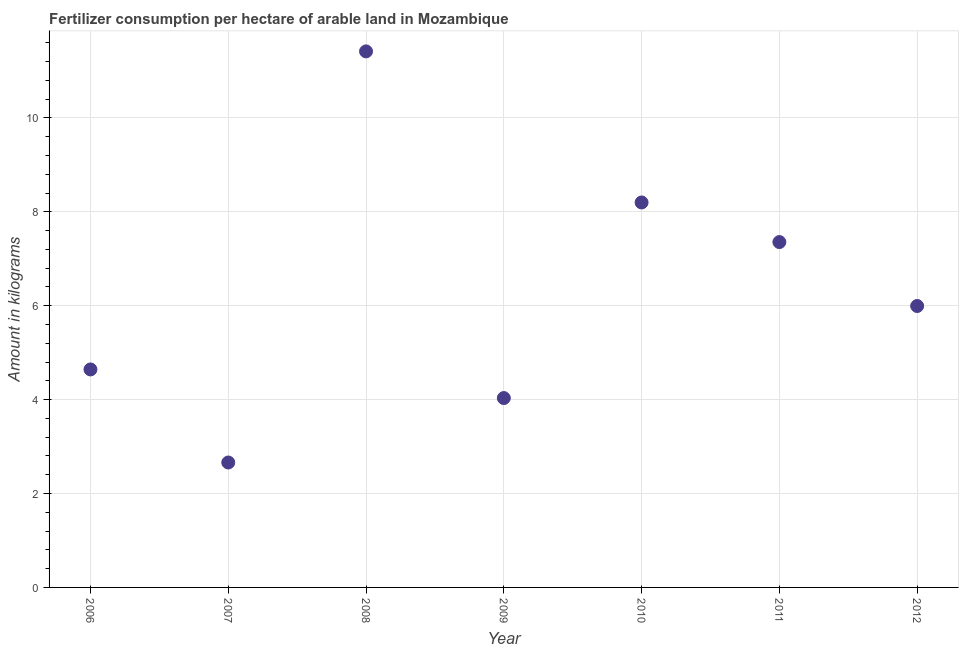What is the amount of fertilizer consumption in 2007?
Provide a short and direct response. 2.66. Across all years, what is the maximum amount of fertilizer consumption?
Your answer should be very brief. 11.42. Across all years, what is the minimum amount of fertilizer consumption?
Provide a short and direct response. 2.66. In which year was the amount of fertilizer consumption maximum?
Make the answer very short. 2008. In which year was the amount of fertilizer consumption minimum?
Your answer should be compact. 2007. What is the sum of the amount of fertilizer consumption?
Offer a terse response. 44.3. What is the difference between the amount of fertilizer consumption in 2009 and 2011?
Make the answer very short. -3.32. What is the average amount of fertilizer consumption per year?
Your answer should be very brief. 6.33. What is the median amount of fertilizer consumption?
Provide a short and direct response. 5.99. Do a majority of the years between 2012 and 2010 (inclusive) have amount of fertilizer consumption greater than 5.6 kg?
Keep it short and to the point. No. What is the ratio of the amount of fertilizer consumption in 2006 to that in 2011?
Provide a short and direct response. 0.63. Is the amount of fertilizer consumption in 2007 less than that in 2011?
Offer a very short reply. Yes. What is the difference between the highest and the second highest amount of fertilizer consumption?
Provide a succinct answer. 3.22. What is the difference between the highest and the lowest amount of fertilizer consumption?
Make the answer very short. 8.76. In how many years, is the amount of fertilizer consumption greater than the average amount of fertilizer consumption taken over all years?
Make the answer very short. 3. How many years are there in the graph?
Provide a short and direct response. 7. What is the difference between two consecutive major ticks on the Y-axis?
Your answer should be very brief. 2. Does the graph contain grids?
Your response must be concise. Yes. What is the title of the graph?
Offer a very short reply. Fertilizer consumption per hectare of arable land in Mozambique . What is the label or title of the Y-axis?
Provide a succinct answer. Amount in kilograms. What is the Amount in kilograms in 2006?
Provide a short and direct response. 4.64. What is the Amount in kilograms in 2007?
Give a very brief answer. 2.66. What is the Amount in kilograms in 2008?
Your response must be concise. 11.42. What is the Amount in kilograms in 2009?
Offer a very short reply. 4.03. What is the Amount in kilograms in 2010?
Give a very brief answer. 8.2. What is the Amount in kilograms in 2011?
Your answer should be compact. 7.36. What is the Amount in kilograms in 2012?
Your answer should be compact. 5.99. What is the difference between the Amount in kilograms in 2006 and 2007?
Offer a terse response. 1.98. What is the difference between the Amount in kilograms in 2006 and 2008?
Your answer should be very brief. -6.77. What is the difference between the Amount in kilograms in 2006 and 2009?
Ensure brevity in your answer.  0.61. What is the difference between the Amount in kilograms in 2006 and 2010?
Offer a very short reply. -3.56. What is the difference between the Amount in kilograms in 2006 and 2011?
Provide a succinct answer. -2.71. What is the difference between the Amount in kilograms in 2006 and 2012?
Your answer should be very brief. -1.35. What is the difference between the Amount in kilograms in 2007 and 2008?
Give a very brief answer. -8.76. What is the difference between the Amount in kilograms in 2007 and 2009?
Offer a terse response. -1.37. What is the difference between the Amount in kilograms in 2007 and 2010?
Ensure brevity in your answer.  -5.54. What is the difference between the Amount in kilograms in 2007 and 2011?
Provide a short and direct response. -4.7. What is the difference between the Amount in kilograms in 2007 and 2012?
Your answer should be very brief. -3.33. What is the difference between the Amount in kilograms in 2008 and 2009?
Provide a short and direct response. 7.38. What is the difference between the Amount in kilograms in 2008 and 2010?
Ensure brevity in your answer.  3.22. What is the difference between the Amount in kilograms in 2008 and 2011?
Your answer should be compact. 4.06. What is the difference between the Amount in kilograms in 2008 and 2012?
Keep it short and to the point. 5.42. What is the difference between the Amount in kilograms in 2009 and 2010?
Ensure brevity in your answer.  -4.17. What is the difference between the Amount in kilograms in 2009 and 2011?
Provide a succinct answer. -3.32. What is the difference between the Amount in kilograms in 2009 and 2012?
Your answer should be compact. -1.96. What is the difference between the Amount in kilograms in 2010 and 2011?
Your answer should be very brief. 0.84. What is the difference between the Amount in kilograms in 2010 and 2012?
Your response must be concise. 2.21. What is the difference between the Amount in kilograms in 2011 and 2012?
Your response must be concise. 1.36. What is the ratio of the Amount in kilograms in 2006 to that in 2007?
Ensure brevity in your answer.  1.75. What is the ratio of the Amount in kilograms in 2006 to that in 2008?
Provide a succinct answer. 0.41. What is the ratio of the Amount in kilograms in 2006 to that in 2009?
Ensure brevity in your answer.  1.15. What is the ratio of the Amount in kilograms in 2006 to that in 2010?
Offer a terse response. 0.57. What is the ratio of the Amount in kilograms in 2006 to that in 2011?
Provide a short and direct response. 0.63. What is the ratio of the Amount in kilograms in 2006 to that in 2012?
Make the answer very short. 0.78. What is the ratio of the Amount in kilograms in 2007 to that in 2008?
Make the answer very short. 0.23. What is the ratio of the Amount in kilograms in 2007 to that in 2009?
Offer a very short reply. 0.66. What is the ratio of the Amount in kilograms in 2007 to that in 2010?
Offer a very short reply. 0.33. What is the ratio of the Amount in kilograms in 2007 to that in 2011?
Provide a short and direct response. 0.36. What is the ratio of the Amount in kilograms in 2007 to that in 2012?
Make the answer very short. 0.44. What is the ratio of the Amount in kilograms in 2008 to that in 2009?
Your response must be concise. 2.83. What is the ratio of the Amount in kilograms in 2008 to that in 2010?
Give a very brief answer. 1.39. What is the ratio of the Amount in kilograms in 2008 to that in 2011?
Offer a terse response. 1.55. What is the ratio of the Amount in kilograms in 2008 to that in 2012?
Your response must be concise. 1.91. What is the ratio of the Amount in kilograms in 2009 to that in 2010?
Your answer should be very brief. 0.49. What is the ratio of the Amount in kilograms in 2009 to that in 2011?
Your answer should be very brief. 0.55. What is the ratio of the Amount in kilograms in 2009 to that in 2012?
Make the answer very short. 0.67. What is the ratio of the Amount in kilograms in 2010 to that in 2011?
Ensure brevity in your answer.  1.11. What is the ratio of the Amount in kilograms in 2010 to that in 2012?
Provide a short and direct response. 1.37. What is the ratio of the Amount in kilograms in 2011 to that in 2012?
Offer a very short reply. 1.23. 